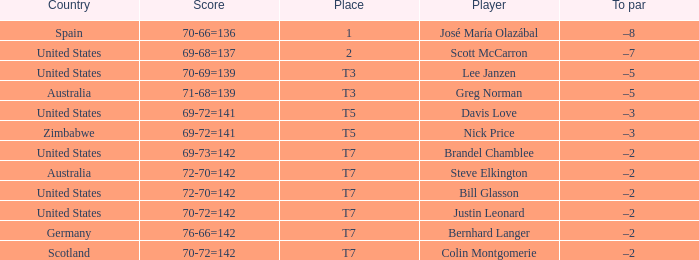Name the Player who has a To par of –2 and a Score of 69-73=142? Brandel Chamblee. 